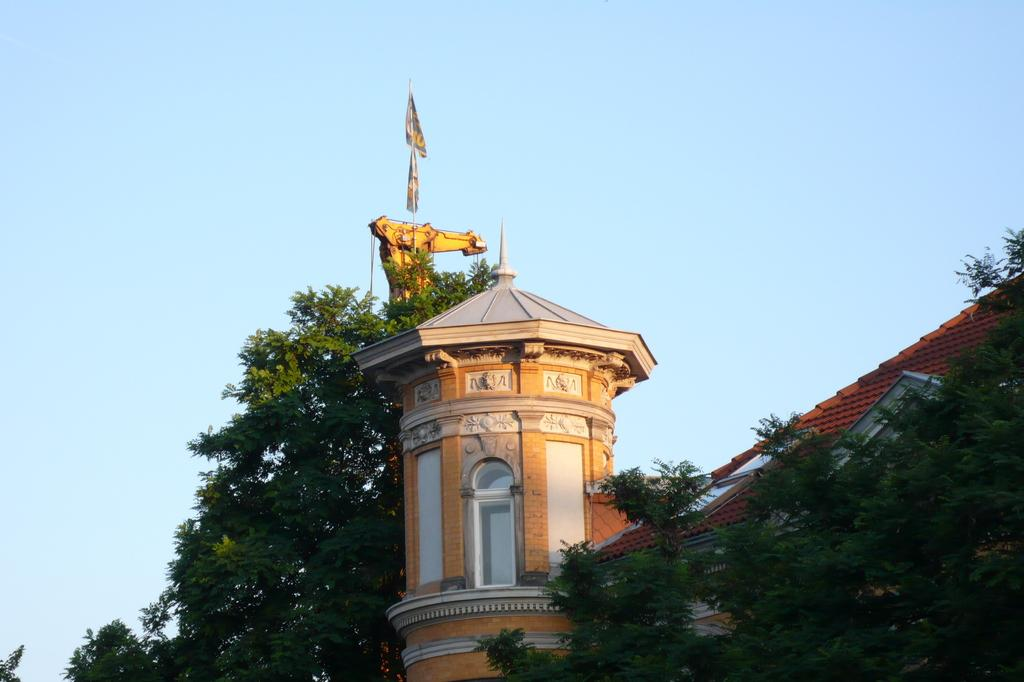What structure is located on the right side of the image? There is a building on the right side of the image. What type of vegetation is on the right side of the image? There are trees on the right side of the image. What is visible in the background of the image? The sky is visible in the background of the image. What type of polish is being applied to the road in the image? There is no road present in the image, and therefore no polish being applied. Who is the partner of the person standing next to the building in the image? There is no person standing next to the building in the image, and therefore no partner to identify. 